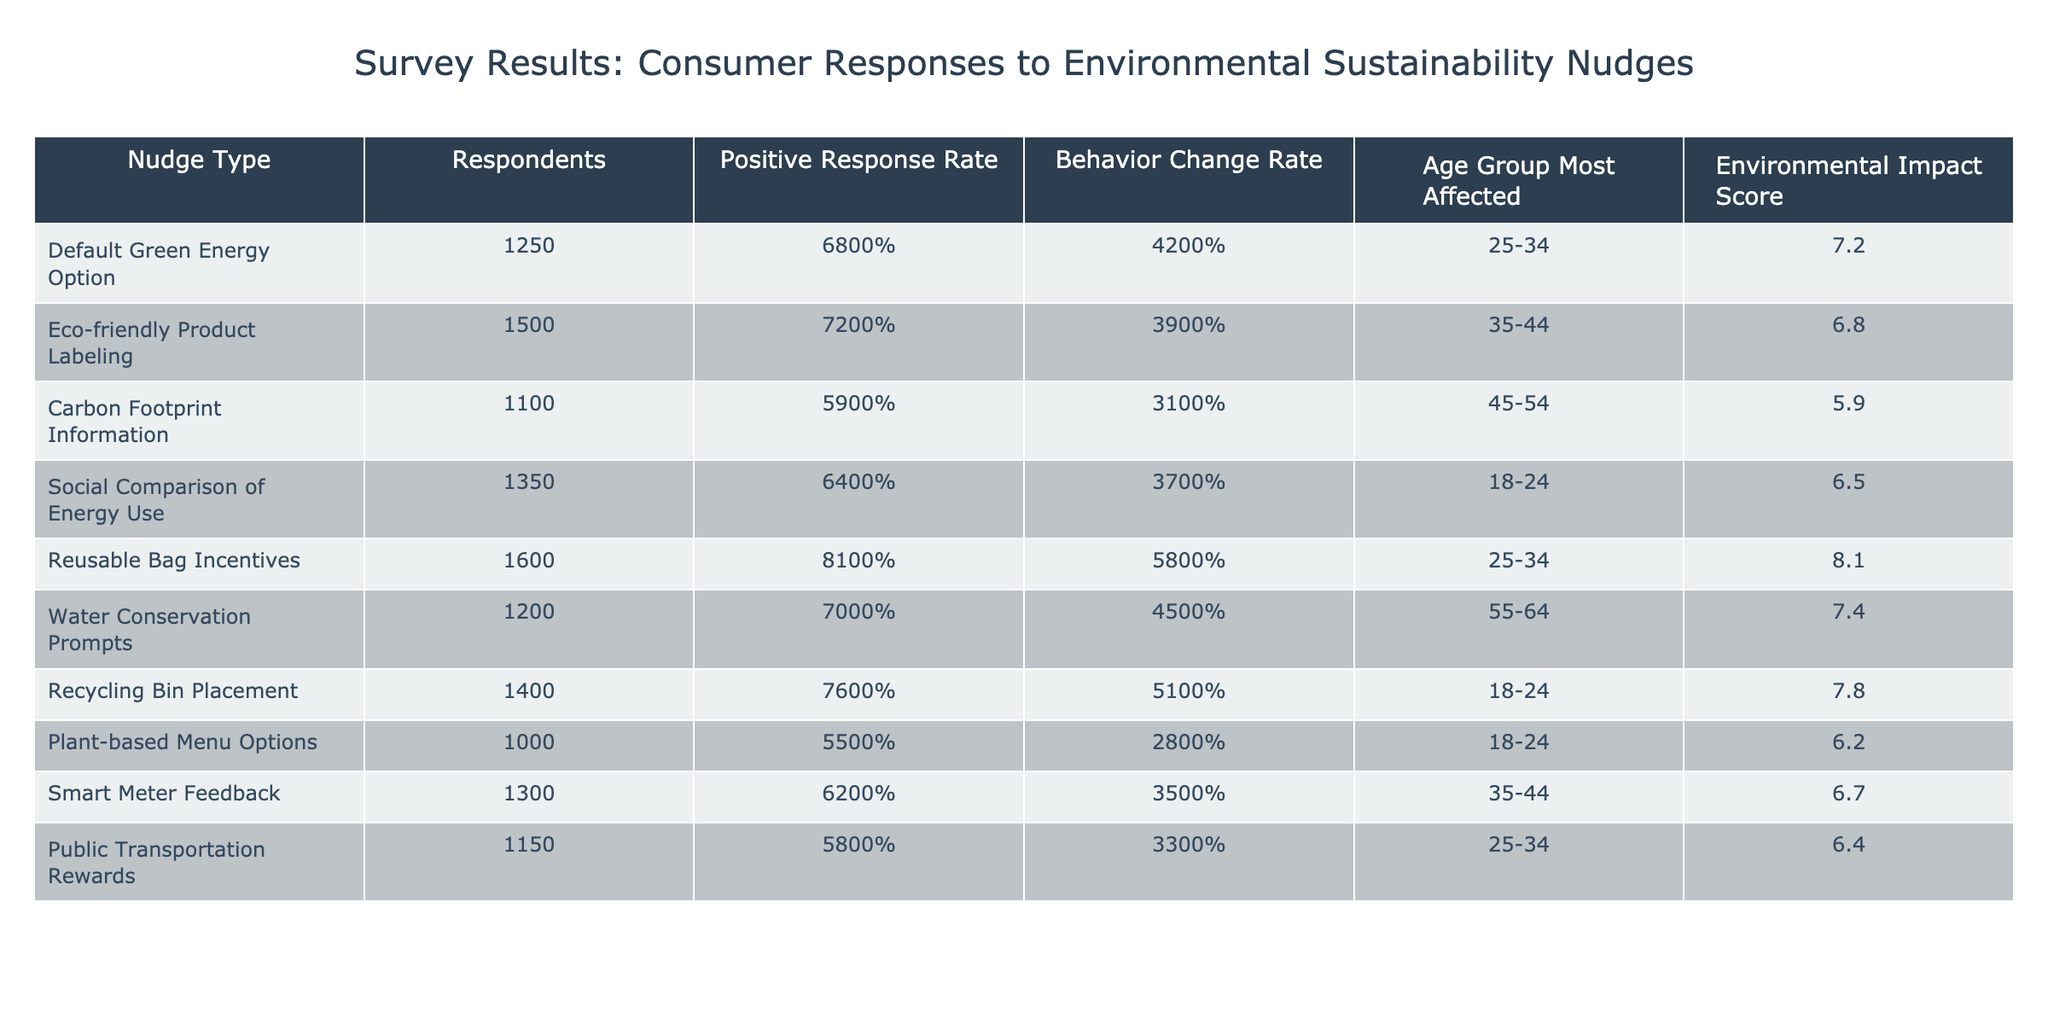What is the Positive Response Rate for Reusable Bag Incentives? The table shows the value for the Positive Response Rate under the "Reusable Bag Incentives" row. It reads 81%.
Answer: 81% Which nudge type had the highest Behavior Change Rate? By comparing the Behavior Change Rate across all nudge types, Reusable Bag Incentives has the highest rate at 58%.
Answer: Reusable Bag Incentives How many respondents were surveyed for the Eco-friendly Product Labeling nudge? The number of respondents for Eco-friendly Product Labeling is found directly in the corresponding row, which states 1500 respondents.
Answer: 1500 True or False: The Carbon Footprint Information nudge had a Positive Response Rate higher than the Social Comparison of Energy Use nudge. The Positive Response Rate for Carbon Footprint Information is 59% while Social Comparison of Energy Use has 64%, which means the statement is False.
Answer: False What is the average Environmental Impact Score for all nudges? The Environmental Impact Scores are 7.2, 6.8, 5.9, 6.5, 8.1, 7.4, 7.8, 6.2, 6.7, and 6.4. The average is calculated by summing these values and dividing by 10. The total is 68.6, so the average is 68.6/10 = 6.86.
Answer: 6.86 Which age group is most affected by the Reusable Bag Incentives nudge? The age group most affected for Reusable Bag Incentives is listed in the "Age Group Most Affected" column for that nudge, which is 25-34.
Answer: 25-34 What is the difference in Positive Response Rates between the Default Green Energy Option and the Recycling Bin Placement nudges? The Positive Response Rate for Default Green Energy Option is 68% and for Recycling Bin Placement is 76%. The difference is calculated as 76% - 68% = 8%.
Answer: 8% Which nudge has the lowest Behavior Change Rate and what is that rate? By examining the Behavior Change Rates, Plant-based Menu Options is the nudge with the lowest rate at 28%.
Answer: 28% How does the Environmental Impact Score of the Water Conservation Prompts compare to Social Comparison of Energy Use? The Environmental Impact Score for Water Conservation Prompts is 7.4 and for Social Comparison of Energy Use it is 6.5. Comparing these shows Water Conservation Prompts has a higher score.
Answer: Water Conservation Prompts has a higher score If we categorize the Positive Response Rates into two groups: above 70% and at or below 70%, how many nudges fall into each category? Counting the nudges, five have a Positive Response Rate above 70% (Reusable Bag Incentives, Eco-friendly Product Labeling, Water Conservation Prompts, Recycling Bin Placement) and five are at or below 70%.
Answer: 5 above 70%, 5 at or below 70% 